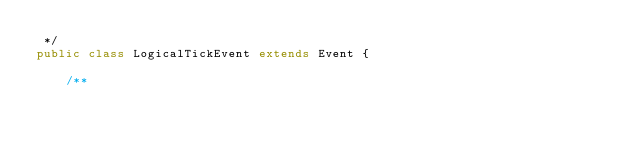<code> <loc_0><loc_0><loc_500><loc_500><_Java_> */
public class LogicalTickEvent extends Event {

    /**</code> 